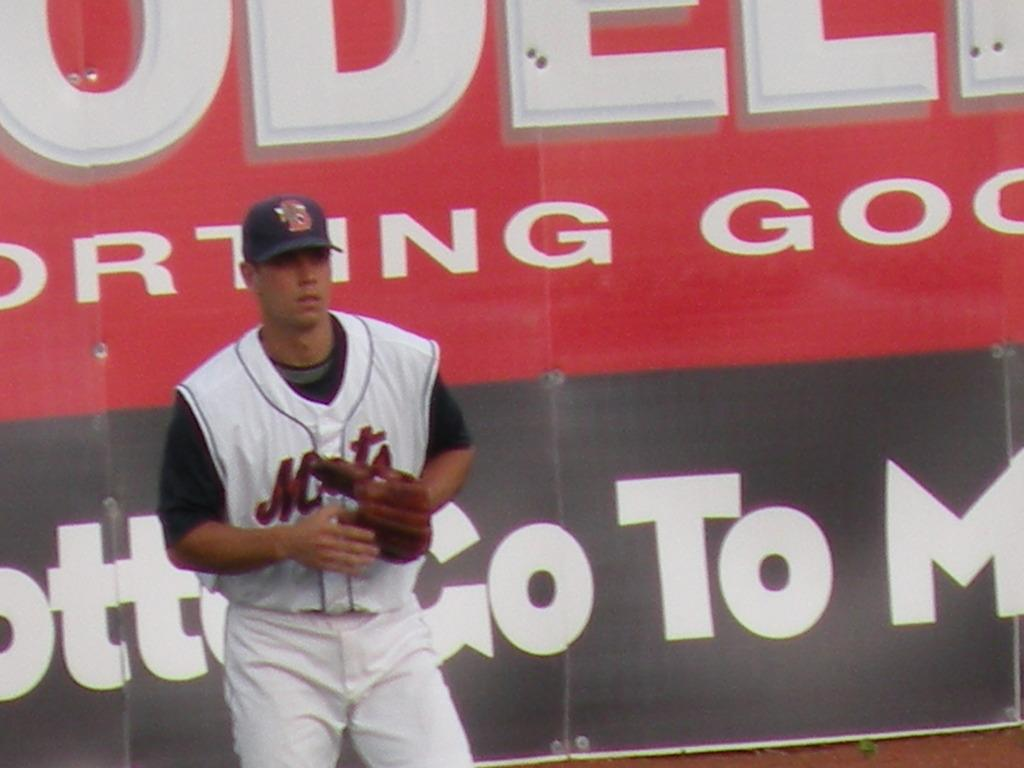<image>
Share a concise interpretation of the image provided. A baseball player for the Mets stands in front og a large billboard. 